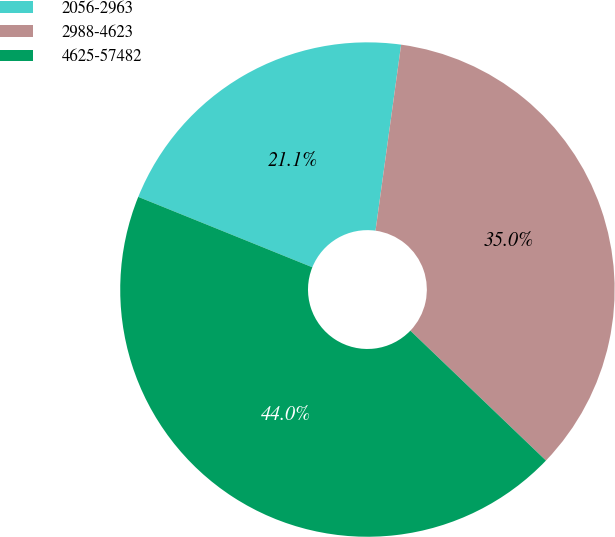Convert chart to OTSL. <chart><loc_0><loc_0><loc_500><loc_500><pie_chart><fcel>2056-2963<fcel>2988-4623<fcel>4625-57482<nl><fcel>21.06%<fcel>34.98%<fcel>43.96%<nl></chart> 